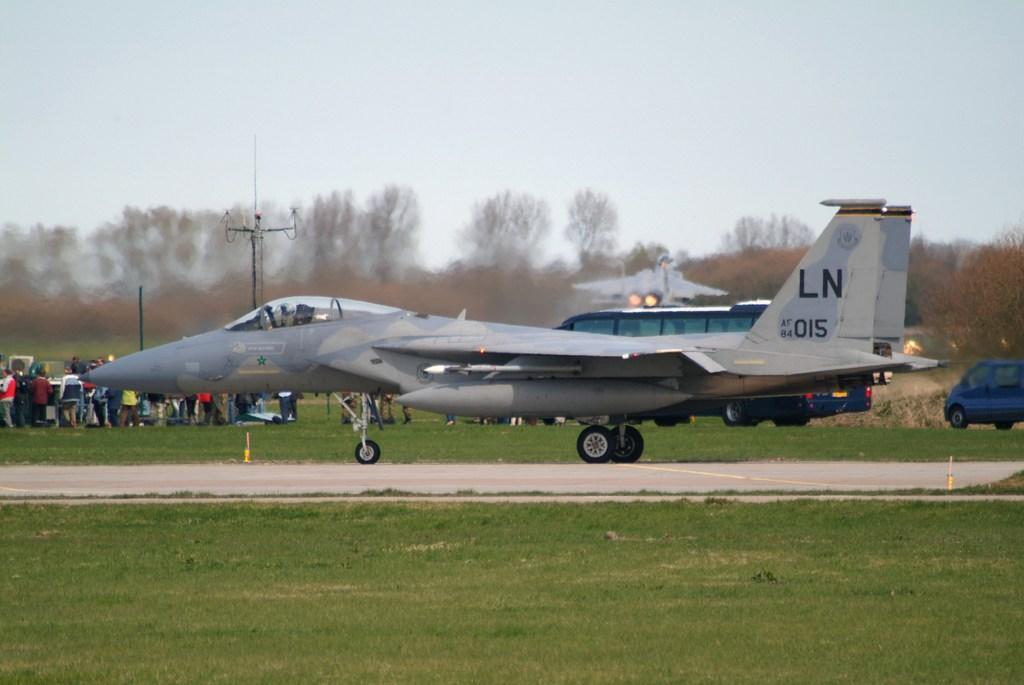<image>
Offer a succinct explanation of the picture presented. the letters LN are on the plane in the day 